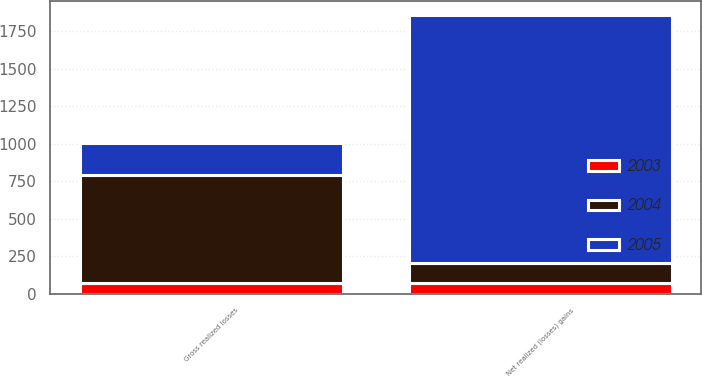<chart> <loc_0><loc_0><loc_500><loc_500><stacked_bar_chart><ecel><fcel>Gross realized losses<fcel>Net realized (losses) gains<nl><fcel>2003<fcel>70<fcel>70<nl><fcel>2004<fcel>723<fcel>138<nl><fcel>2005<fcel>213<fcel>1646<nl></chart> 